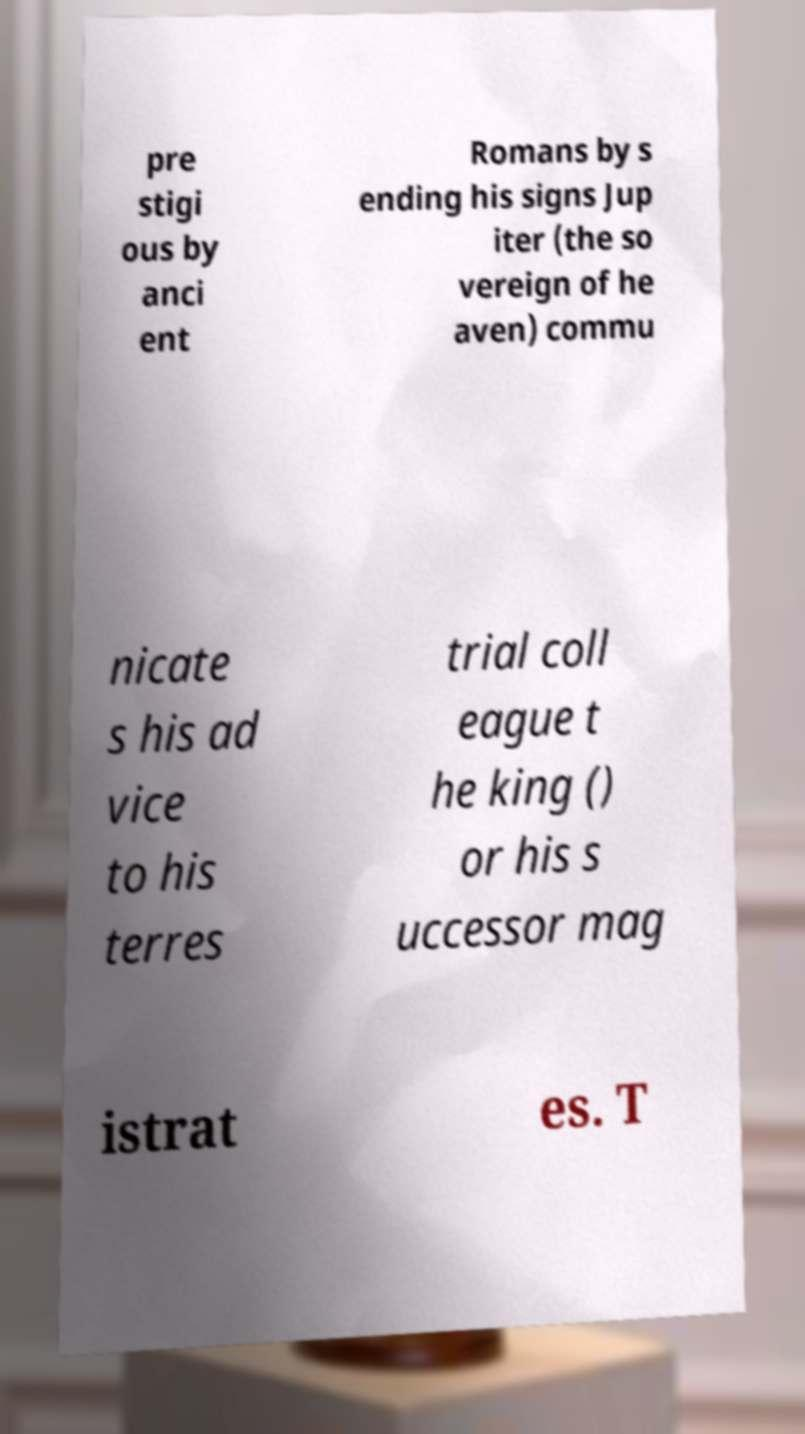Can you read and provide the text displayed in the image?This photo seems to have some interesting text. Can you extract and type it out for me? pre stigi ous by anci ent Romans by s ending his signs Jup iter (the so vereign of he aven) commu nicate s his ad vice to his terres trial coll eague t he king () or his s uccessor mag istrat es. T 